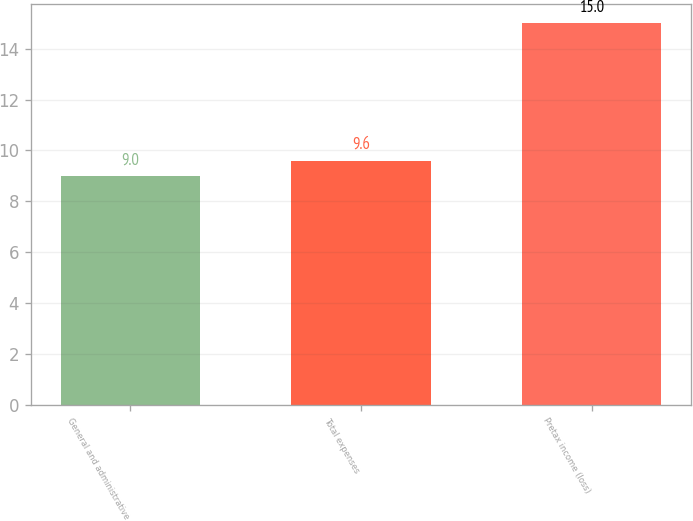Convert chart. <chart><loc_0><loc_0><loc_500><loc_500><bar_chart><fcel>General and administrative<fcel>Total expenses<fcel>Pretax income (loss)<nl><fcel>9<fcel>9.6<fcel>15<nl></chart> 